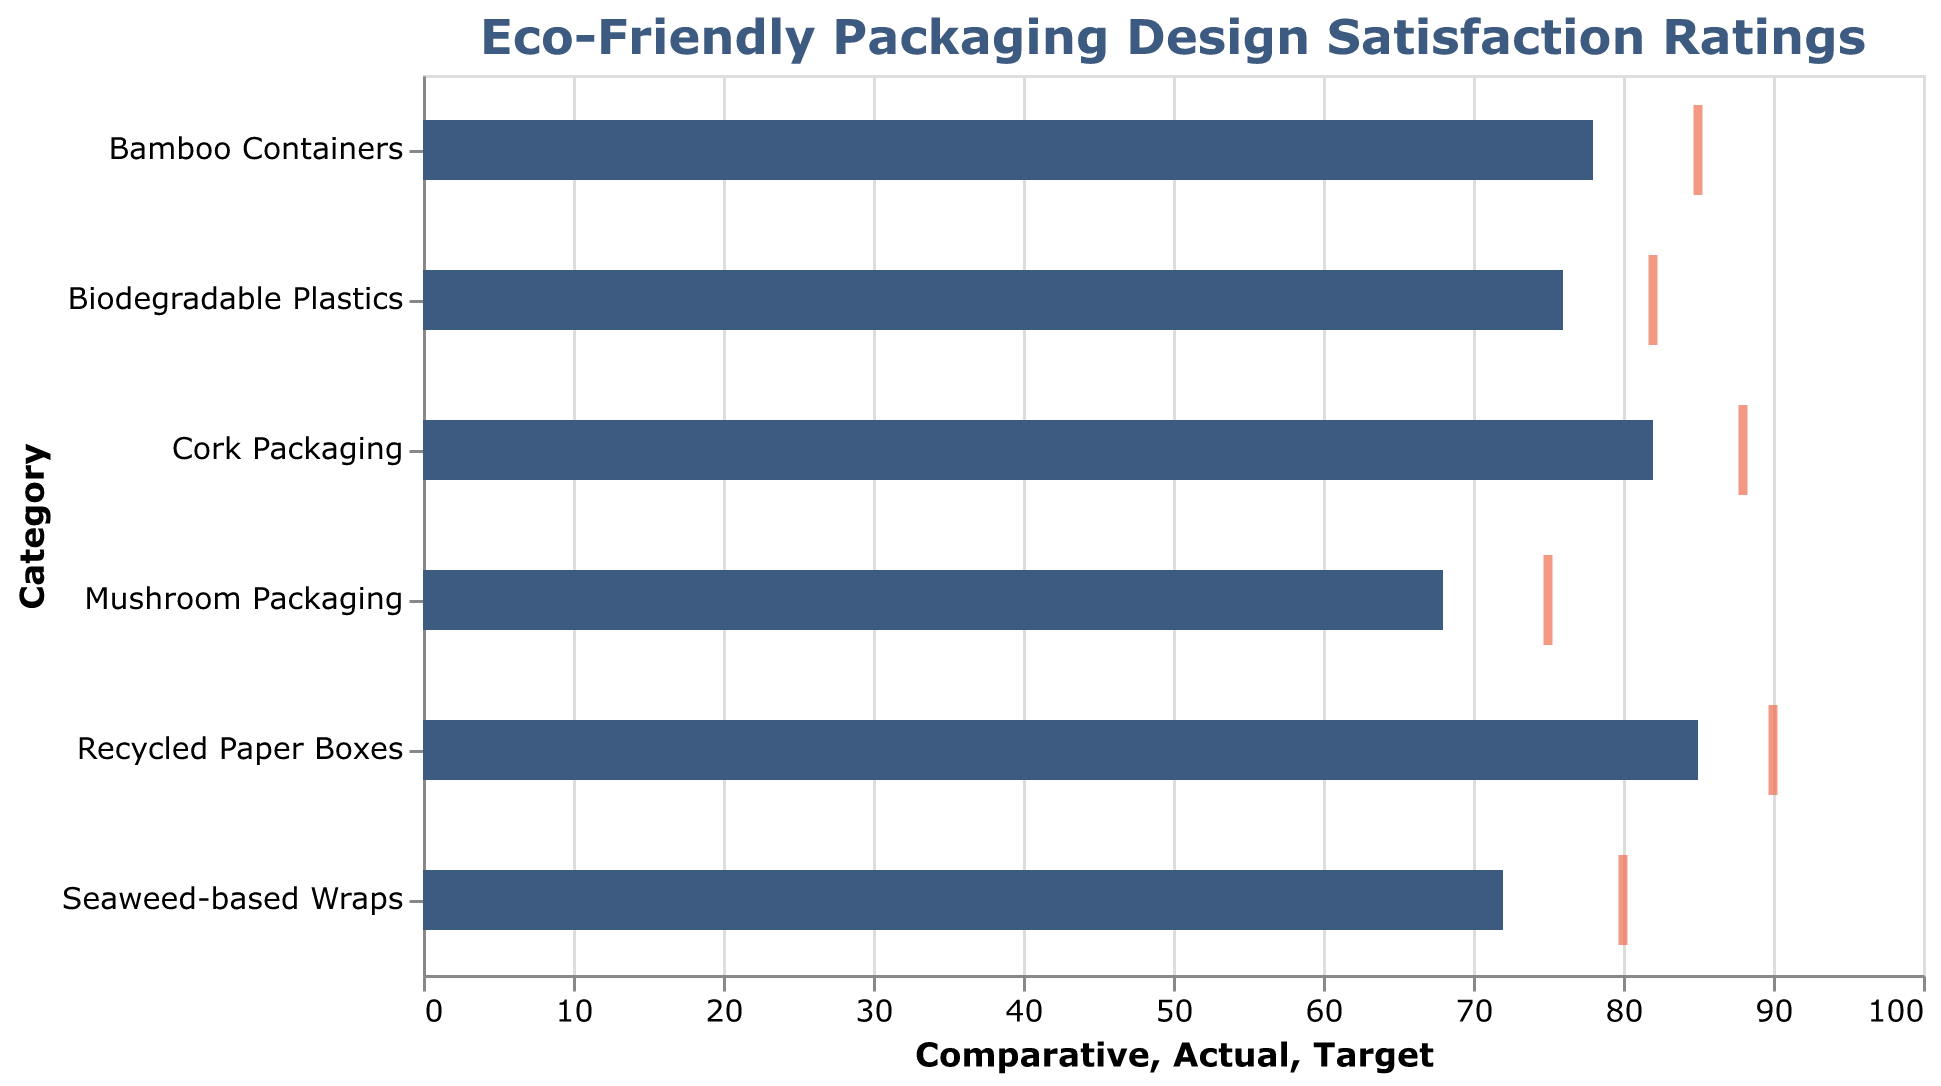What is the title of the plot? The title is clearly mentioned on the top, which reads, "Eco-Friendly Packaging Design Satisfaction Ratings".
Answer: Eco-Friendly Packaging Design Satisfaction Ratings How many categories of packaging designs are compared in the chart? The chart displays different bars for each category, and counting these, there are six distinct categories.
Answer: Six What color represents the actual satisfaction ratings? The actual satisfaction ratings are represented by the dark blue bars.
Answer: Dark blue Which packaging design has the highest actual satisfaction rating? By looking at the lengths of the dark blue bars, it is evident that "Recycled Paper Boxes" has the highest actual satisfaction rating at 85.
Answer: Recycled Paper Boxes What is the target satisfaction rating for Bamboo Containers? The target ratings are represented by the thick orange ticks. The Bamboo Containers' target satisfaction rating is 85.
Answer: 85 How much higher is the actual satisfaction rating of Cork Packaging than its comparative satisfaction rating? Cork Packaging's actual rating is 82, and the comparative rating is 72. The difference is 82 - 72.
Answer: 10 Which two packaging designs have the closest actual satisfaction ratings? By comparing the lengths of the dark blue bars, "Biodegradable Plastics" (76) and "Bamboo Containers" (78) have the closest actual ratings, differing by only 2 points.
Answer: Biodegradable Plastics and Bamboo Containers Is the actual satisfaction rating for Mushroom Packaging above or below its target? Mushroom Packaging has an actual satisfaction rating of 68, whereas the target is 75. Therefore, the actual rating is below the target.
Answer: Below Calculate the average comparative satisfaction rating across all categories. Sum the comparative satisfaction ratings (75 + 70 + 65 + 60 + 72 + 68) = 410. There are 6 categories, so divide 410 by 6.
Answer: 68.33 Which packaging design is closest to meeting its target satisfaction rating? By comparing the lengths of the dark blue bars and the positions of the orange ticks, "Biodegradable Plastics" has an actual rating (76) closest to its target (82), with a difference of 6.
Answer: Biodegradable Plastics 